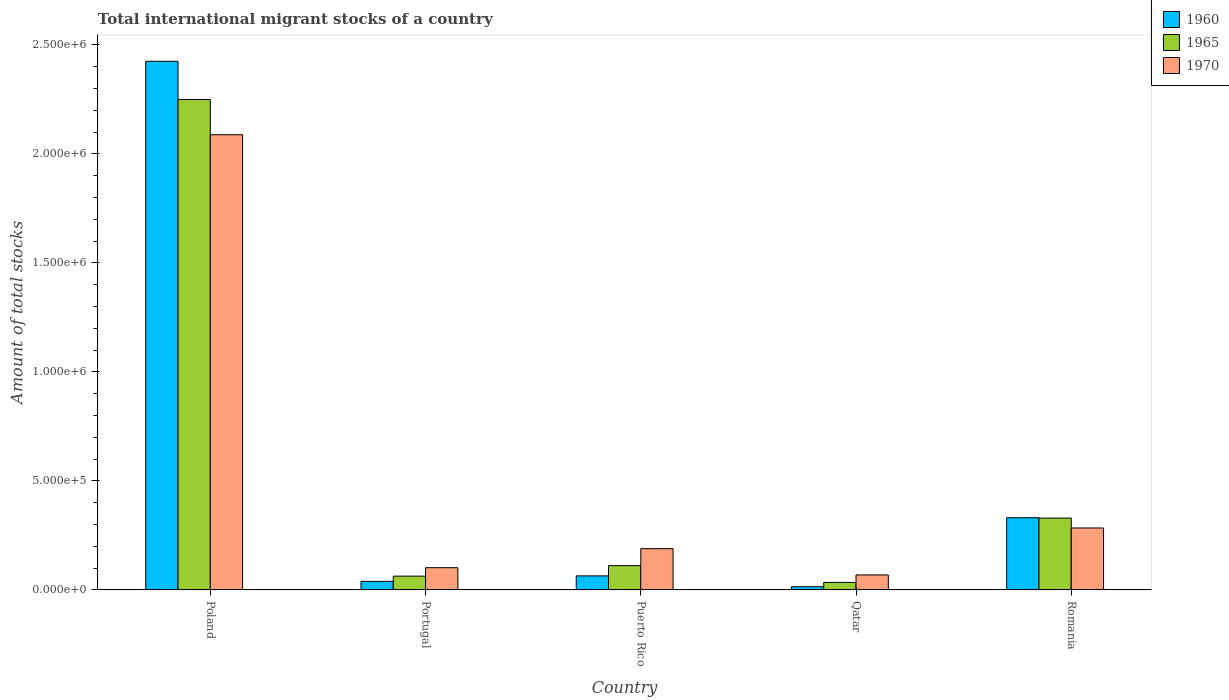Are the number of bars per tick equal to the number of legend labels?
Offer a very short reply. Yes. How many bars are there on the 5th tick from the left?
Your response must be concise. 3. What is the label of the 5th group of bars from the left?
Make the answer very short. Romania. What is the amount of total stocks in in 1965 in Romania?
Give a very brief answer. 3.29e+05. Across all countries, what is the maximum amount of total stocks in in 1970?
Provide a short and direct response. 2.09e+06. Across all countries, what is the minimum amount of total stocks in in 1965?
Your answer should be very brief. 3.41e+04. In which country was the amount of total stocks in in 1965 minimum?
Make the answer very short. Qatar. What is the total amount of total stocks in in 1960 in the graph?
Ensure brevity in your answer.  2.87e+06. What is the difference between the amount of total stocks in in 1960 in Portugal and that in Puerto Rico?
Provide a succinct answer. -2.52e+04. What is the difference between the amount of total stocks in in 1965 in Portugal and the amount of total stocks in in 1970 in Puerto Rico?
Make the answer very short. -1.26e+05. What is the average amount of total stocks in in 1970 per country?
Offer a terse response. 5.46e+05. What is the difference between the amount of total stocks in of/in 1965 and amount of total stocks in of/in 1970 in Poland?
Your response must be concise. 1.62e+05. In how many countries, is the amount of total stocks in in 1970 greater than 600000?
Ensure brevity in your answer.  1. What is the ratio of the amount of total stocks in in 1960 in Poland to that in Portugal?
Your answer should be compact. 62.34. Is the difference between the amount of total stocks in in 1965 in Poland and Portugal greater than the difference between the amount of total stocks in in 1970 in Poland and Portugal?
Your answer should be compact. Yes. What is the difference between the highest and the second highest amount of total stocks in in 1965?
Make the answer very short. -2.14e+06. What is the difference between the highest and the lowest amount of total stocks in in 1970?
Your answer should be compact. 2.02e+06. Is the sum of the amount of total stocks in in 1970 in Poland and Qatar greater than the maximum amount of total stocks in in 1965 across all countries?
Provide a short and direct response. No. What does the 1st bar from the left in Romania represents?
Keep it short and to the point. 1960. What does the 3rd bar from the right in Portugal represents?
Keep it short and to the point. 1960. Are all the bars in the graph horizontal?
Provide a succinct answer. No. What is the difference between two consecutive major ticks on the Y-axis?
Your answer should be compact. 5.00e+05. Are the values on the major ticks of Y-axis written in scientific E-notation?
Ensure brevity in your answer.  Yes. Does the graph contain any zero values?
Make the answer very short. No. Where does the legend appear in the graph?
Ensure brevity in your answer.  Top right. How many legend labels are there?
Your answer should be very brief. 3. How are the legend labels stacked?
Your answer should be compact. Vertical. What is the title of the graph?
Make the answer very short. Total international migrant stocks of a country. Does "2014" appear as one of the legend labels in the graph?
Keep it short and to the point. No. What is the label or title of the Y-axis?
Your answer should be compact. Amount of total stocks. What is the Amount of total stocks in 1960 in Poland?
Your answer should be very brief. 2.42e+06. What is the Amount of total stocks of 1965 in Poland?
Provide a succinct answer. 2.25e+06. What is the Amount of total stocks of 1970 in Poland?
Offer a terse response. 2.09e+06. What is the Amount of total stocks of 1960 in Portugal?
Ensure brevity in your answer.  3.89e+04. What is the Amount of total stocks of 1965 in Portugal?
Your answer should be compact. 6.29e+04. What is the Amount of total stocks of 1970 in Portugal?
Make the answer very short. 1.02e+05. What is the Amount of total stocks in 1960 in Puerto Rico?
Your response must be concise. 6.41e+04. What is the Amount of total stocks in 1965 in Puerto Rico?
Provide a short and direct response. 1.11e+05. What is the Amount of total stocks of 1970 in Puerto Rico?
Provide a succinct answer. 1.89e+05. What is the Amount of total stocks in 1960 in Qatar?
Your answer should be compact. 1.44e+04. What is the Amount of total stocks of 1965 in Qatar?
Keep it short and to the point. 3.41e+04. What is the Amount of total stocks in 1970 in Qatar?
Your answer should be compact. 6.83e+04. What is the Amount of total stocks in 1960 in Romania?
Make the answer very short. 3.31e+05. What is the Amount of total stocks of 1965 in Romania?
Offer a very short reply. 3.29e+05. What is the Amount of total stocks in 1970 in Romania?
Give a very brief answer. 2.84e+05. Across all countries, what is the maximum Amount of total stocks in 1960?
Make the answer very short. 2.42e+06. Across all countries, what is the maximum Amount of total stocks in 1965?
Provide a short and direct response. 2.25e+06. Across all countries, what is the maximum Amount of total stocks of 1970?
Your answer should be very brief. 2.09e+06. Across all countries, what is the minimum Amount of total stocks of 1960?
Your response must be concise. 1.44e+04. Across all countries, what is the minimum Amount of total stocks of 1965?
Offer a terse response. 3.41e+04. Across all countries, what is the minimum Amount of total stocks of 1970?
Offer a very short reply. 6.83e+04. What is the total Amount of total stocks in 1960 in the graph?
Ensure brevity in your answer.  2.87e+06. What is the total Amount of total stocks in 1965 in the graph?
Offer a terse response. 2.79e+06. What is the total Amount of total stocks of 1970 in the graph?
Provide a succinct answer. 2.73e+06. What is the difference between the Amount of total stocks of 1960 in Poland and that in Portugal?
Offer a terse response. 2.39e+06. What is the difference between the Amount of total stocks of 1965 in Poland and that in Portugal?
Your answer should be compact. 2.19e+06. What is the difference between the Amount of total stocks in 1970 in Poland and that in Portugal?
Your response must be concise. 1.99e+06. What is the difference between the Amount of total stocks in 1960 in Poland and that in Puerto Rico?
Make the answer very short. 2.36e+06. What is the difference between the Amount of total stocks in 1965 in Poland and that in Puerto Rico?
Your answer should be very brief. 2.14e+06. What is the difference between the Amount of total stocks of 1970 in Poland and that in Puerto Rico?
Your response must be concise. 1.90e+06. What is the difference between the Amount of total stocks in 1960 in Poland and that in Qatar?
Provide a short and direct response. 2.41e+06. What is the difference between the Amount of total stocks in 1965 in Poland and that in Qatar?
Offer a very short reply. 2.22e+06. What is the difference between the Amount of total stocks in 1970 in Poland and that in Qatar?
Provide a short and direct response. 2.02e+06. What is the difference between the Amount of total stocks of 1960 in Poland and that in Romania?
Give a very brief answer. 2.09e+06. What is the difference between the Amount of total stocks of 1965 in Poland and that in Romania?
Make the answer very short. 1.92e+06. What is the difference between the Amount of total stocks in 1970 in Poland and that in Romania?
Offer a terse response. 1.80e+06. What is the difference between the Amount of total stocks in 1960 in Portugal and that in Puerto Rico?
Your answer should be compact. -2.52e+04. What is the difference between the Amount of total stocks of 1965 in Portugal and that in Puerto Rico?
Keep it short and to the point. -4.82e+04. What is the difference between the Amount of total stocks of 1970 in Portugal and that in Puerto Rico?
Provide a short and direct response. -8.73e+04. What is the difference between the Amount of total stocks in 1960 in Portugal and that in Qatar?
Offer a very short reply. 2.45e+04. What is the difference between the Amount of total stocks in 1965 in Portugal and that in Qatar?
Your answer should be compact. 2.88e+04. What is the difference between the Amount of total stocks of 1970 in Portugal and that in Qatar?
Ensure brevity in your answer.  3.33e+04. What is the difference between the Amount of total stocks in 1960 in Portugal and that in Romania?
Give a very brief answer. -2.92e+05. What is the difference between the Amount of total stocks in 1965 in Portugal and that in Romania?
Your answer should be very brief. -2.66e+05. What is the difference between the Amount of total stocks in 1970 in Portugal and that in Romania?
Offer a very short reply. -1.82e+05. What is the difference between the Amount of total stocks in 1960 in Puerto Rico and that in Qatar?
Your answer should be compact. 4.97e+04. What is the difference between the Amount of total stocks in 1965 in Puerto Rico and that in Qatar?
Ensure brevity in your answer.  7.69e+04. What is the difference between the Amount of total stocks of 1970 in Puerto Rico and that in Qatar?
Your answer should be very brief. 1.21e+05. What is the difference between the Amount of total stocks in 1960 in Puerto Rico and that in Romania?
Offer a terse response. -2.67e+05. What is the difference between the Amount of total stocks in 1965 in Puerto Rico and that in Romania?
Your response must be concise. -2.18e+05. What is the difference between the Amount of total stocks of 1970 in Puerto Rico and that in Romania?
Make the answer very short. -9.49e+04. What is the difference between the Amount of total stocks in 1960 in Qatar and that in Romania?
Provide a succinct answer. -3.16e+05. What is the difference between the Amount of total stocks in 1965 in Qatar and that in Romania?
Your response must be concise. -2.95e+05. What is the difference between the Amount of total stocks of 1970 in Qatar and that in Romania?
Keep it short and to the point. -2.15e+05. What is the difference between the Amount of total stocks of 1960 in Poland and the Amount of total stocks of 1965 in Portugal?
Offer a terse response. 2.36e+06. What is the difference between the Amount of total stocks in 1960 in Poland and the Amount of total stocks in 1970 in Portugal?
Give a very brief answer. 2.32e+06. What is the difference between the Amount of total stocks of 1965 in Poland and the Amount of total stocks of 1970 in Portugal?
Provide a short and direct response. 2.15e+06. What is the difference between the Amount of total stocks in 1960 in Poland and the Amount of total stocks in 1965 in Puerto Rico?
Make the answer very short. 2.31e+06. What is the difference between the Amount of total stocks in 1960 in Poland and the Amount of total stocks in 1970 in Puerto Rico?
Make the answer very short. 2.24e+06. What is the difference between the Amount of total stocks in 1965 in Poland and the Amount of total stocks in 1970 in Puerto Rico?
Offer a terse response. 2.06e+06. What is the difference between the Amount of total stocks of 1960 in Poland and the Amount of total stocks of 1965 in Qatar?
Your answer should be compact. 2.39e+06. What is the difference between the Amount of total stocks of 1960 in Poland and the Amount of total stocks of 1970 in Qatar?
Your answer should be compact. 2.36e+06. What is the difference between the Amount of total stocks in 1965 in Poland and the Amount of total stocks in 1970 in Qatar?
Provide a succinct answer. 2.18e+06. What is the difference between the Amount of total stocks in 1960 in Poland and the Amount of total stocks in 1965 in Romania?
Give a very brief answer. 2.10e+06. What is the difference between the Amount of total stocks of 1960 in Poland and the Amount of total stocks of 1970 in Romania?
Your answer should be compact. 2.14e+06. What is the difference between the Amount of total stocks of 1965 in Poland and the Amount of total stocks of 1970 in Romania?
Provide a short and direct response. 1.97e+06. What is the difference between the Amount of total stocks in 1960 in Portugal and the Amount of total stocks in 1965 in Puerto Rico?
Your answer should be very brief. -7.21e+04. What is the difference between the Amount of total stocks in 1960 in Portugal and the Amount of total stocks in 1970 in Puerto Rico?
Keep it short and to the point. -1.50e+05. What is the difference between the Amount of total stocks in 1965 in Portugal and the Amount of total stocks in 1970 in Puerto Rico?
Offer a very short reply. -1.26e+05. What is the difference between the Amount of total stocks of 1960 in Portugal and the Amount of total stocks of 1965 in Qatar?
Your response must be concise. 4808. What is the difference between the Amount of total stocks of 1960 in Portugal and the Amount of total stocks of 1970 in Qatar?
Provide a short and direct response. -2.94e+04. What is the difference between the Amount of total stocks of 1965 in Portugal and the Amount of total stocks of 1970 in Qatar?
Make the answer very short. -5463. What is the difference between the Amount of total stocks of 1960 in Portugal and the Amount of total stocks of 1965 in Romania?
Provide a short and direct response. -2.90e+05. What is the difference between the Amount of total stocks of 1960 in Portugal and the Amount of total stocks of 1970 in Romania?
Keep it short and to the point. -2.45e+05. What is the difference between the Amount of total stocks of 1965 in Portugal and the Amount of total stocks of 1970 in Romania?
Your answer should be very brief. -2.21e+05. What is the difference between the Amount of total stocks of 1960 in Puerto Rico and the Amount of total stocks of 1965 in Qatar?
Offer a very short reply. 3.00e+04. What is the difference between the Amount of total stocks of 1960 in Puerto Rico and the Amount of total stocks of 1970 in Qatar?
Offer a terse response. -4276. What is the difference between the Amount of total stocks in 1965 in Puerto Rico and the Amount of total stocks in 1970 in Qatar?
Offer a very short reply. 4.27e+04. What is the difference between the Amount of total stocks in 1960 in Puerto Rico and the Amount of total stocks in 1965 in Romania?
Provide a succinct answer. -2.65e+05. What is the difference between the Amount of total stocks in 1960 in Puerto Rico and the Amount of total stocks in 1970 in Romania?
Ensure brevity in your answer.  -2.20e+05. What is the difference between the Amount of total stocks of 1965 in Puerto Rico and the Amount of total stocks of 1970 in Romania?
Offer a terse response. -1.73e+05. What is the difference between the Amount of total stocks in 1960 in Qatar and the Amount of total stocks in 1965 in Romania?
Your answer should be compact. -3.15e+05. What is the difference between the Amount of total stocks in 1960 in Qatar and the Amount of total stocks in 1970 in Romania?
Your response must be concise. -2.69e+05. What is the difference between the Amount of total stocks in 1965 in Qatar and the Amount of total stocks in 1970 in Romania?
Provide a short and direct response. -2.50e+05. What is the average Amount of total stocks of 1960 per country?
Your response must be concise. 5.75e+05. What is the average Amount of total stocks of 1965 per country?
Make the answer very short. 5.57e+05. What is the average Amount of total stocks of 1970 per country?
Make the answer very short. 5.46e+05. What is the difference between the Amount of total stocks of 1960 and Amount of total stocks of 1965 in Poland?
Offer a very short reply. 1.75e+05. What is the difference between the Amount of total stocks of 1960 and Amount of total stocks of 1970 in Poland?
Offer a very short reply. 3.37e+05. What is the difference between the Amount of total stocks in 1965 and Amount of total stocks in 1970 in Poland?
Provide a succinct answer. 1.62e+05. What is the difference between the Amount of total stocks of 1960 and Amount of total stocks of 1965 in Portugal?
Offer a terse response. -2.40e+04. What is the difference between the Amount of total stocks of 1960 and Amount of total stocks of 1970 in Portugal?
Offer a very short reply. -6.27e+04. What is the difference between the Amount of total stocks of 1965 and Amount of total stocks of 1970 in Portugal?
Your answer should be very brief. -3.88e+04. What is the difference between the Amount of total stocks of 1960 and Amount of total stocks of 1965 in Puerto Rico?
Your answer should be compact. -4.70e+04. What is the difference between the Amount of total stocks in 1960 and Amount of total stocks in 1970 in Puerto Rico?
Make the answer very short. -1.25e+05. What is the difference between the Amount of total stocks of 1965 and Amount of total stocks of 1970 in Puerto Rico?
Your response must be concise. -7.79e+04. What is the difference between the Amount of total stocks in 1960 and Amount of total stocks in 1965 in Qatar?
Ensure brevity in your answer.  -1.97e+04. What is the difference between the Amount of total stocks of 1960 and Amount of total stocks of 1970 in Qatar?
Make the answer very short. -5.39e+04. What is the difference between the Amount of total stocks in 1965 and Amount of total stocks in 1970 in Qatar?
Offer a very short reply. -3.42e+04. What is the difference between the Amount of total stocks in 1960 and Amount of total stocks in 1965 in Romania?
Keep it short and to the point. 1650. What is the difference between the Amount of total stocks of 1960 and Amount of total stocks of 1970 in Romania?
Your answer should be very brief. 4.70e+04. What is the difference between the Amount of total stocks of 1965 and Amount of total stocks of 1970 in Romania?
Your answer should be very brief. 4.54e+04. What is the ratio of the Amount of total stocks of 1960 in Poland to that in Portugal?
Provide a short and direct response. 62.34. What is the ratio of the Amount of total stocks in 1965 in Poland to that in Portugal?
Provide a short and direct response. 35.78. What is the ratio of the Amount of total stocks of 1970 in Poland to that in Portugal?
Ensure brevity in your answer.  20.54. What is the ratio of the Amount of total stocks of 1960 in Poland to that in Puerto Rico?
Make the answer very short. 37.85. What is the ratio of the Amount of total stocks in 1965 in Poland to that in Puerto Rico?
Make the answer very short. 20.26. What is the ratio of the Amount of total stocks in 1970 in Poland to that in Puerto Rico?
Make the answer very short. 11.05. What is the ratio of the Amount of total stocks in 1960 in Poland to that in Qatar?
Offer a very short reply. 168.39. What is the ratio of the Amount of total stocks in 1965 in Poland to that in Qatar?
Your answer should be very brief. 65.99. What is the ratio of the Amount of total stocks in 1970 in Poland to that in Qatar?
Keep it short and to the point. 30.55. What is the ratio of the Amount of total stocks of 1960 in Poland to that in Romania?
Your answer should be compact. 7.33. What is the ratio of the Amount of total stocks in 1965 in Poland to that in Romania?
Provide a short and direct response. 6.83. What is the ratio of the Amount of total stocks in 1970 in Poland to that in Romania?
Make the answer very short. 7.36. What is the ratio of the Amount of total stocks in 1960 in Portugal to that in Puerto Rico?
Your response must be concise. 0.61. What is the ratio of the Amount of total stocks in 1965 in Portugal to that in Puerto Rico?
Give a very brief answer. 0.57. What is the ratio of the Amount of total stocks in 1970 in Portugal to that in Puerto Rico?
Ensure brevity in your answer.  0.54. What is the ratio of the Amount of total stocks of 1960 in Portugal to that in Qatar?
Your response must be concise. 2.7. What is the ratio of the Amount of total stocks in 1965 in Portugal to that in Qatar?
Provide a short and direct response. 1.84. What is the ratio of the Amount of total stocks in 1970 in Portugal to that in Qatar?
Ensure brevity in your answer.  1.49. What is the ratio of the Amount of total stocks in 1960 in Portugal to that in Romania?
Your answer should be compact. 0.12. What is the ratio of the Amount of total stocks in 1965 in Portugal to that in Romania?
Offer a terse response. 0.19. What is the ratio of the Amount of total stocks of 1970 in Portugal to that in Romania?
Offer a very short reply. 0.36. What is the ratio of the Amount of total stocks in 1960 in Puerto Rico to that in Qatar?
Make the answer very short. 4.45. What is the ratio of the Amount of total stocks in 1965 in Puerto Rico to that in Qatar?
Give a very brief answer. 3.26. What is the ratio of the Amount of total stocks in 1970 in Puerto Rico to that in Qatar?
Your answer should be very brief. 2.77. What is the ratio of the Amount of total stocks of 1960 in Puerto Rico to that in Romania?
Keep it short and to the point. 0.19. What is the ratio of the Amount of total stocks in 1965 in Puerto Rico to that in Romania?
Your answer should be compact. 0.34. What is the ratio of the Amount of total stocks in 1970 in Puerto Rico to that in Romania?
Your answer should be very brief. 0.67. What is the ratio of the Amount of total stocks in 1960 in Qatar to that in Romania?
Ensure brevity in your answer.  0.04. What is the ratio of the Amount of total stocks of 1965 in Qatar to that in Romania?
Ensure brevity in your answer.  0.1. What is the ratio of the Amount of total stocks of 1970 in Qatar to that in Romania?
Ensure brevity in your answer.  0.24. What is the difference between the highest and the second highest Amount of total stocks in 1960?
Keep it short and to the point. 2.09e+06. What is the difference between the highest and the second highest Amount of total stocks in 1965?
Ensure brevity in your answer.  1.92e+06. What is the difference between the highest and the second highest Amount of total stocks of 1970?
Ensure brevity in your answer.  1.80e+06. What is the difference between the highest and the lowest Amount of total stocks of 1960?
Your response must be concise. 2.41e+06. What is the difference between the highest and the lowest Amount of total stocks in 1965?
Provide a succinct answer. 2.22e+06. What is the difference between the highest and the lowest Amount of total stocks of 1970?
Provide a succinct answer. 2.02e+06. 